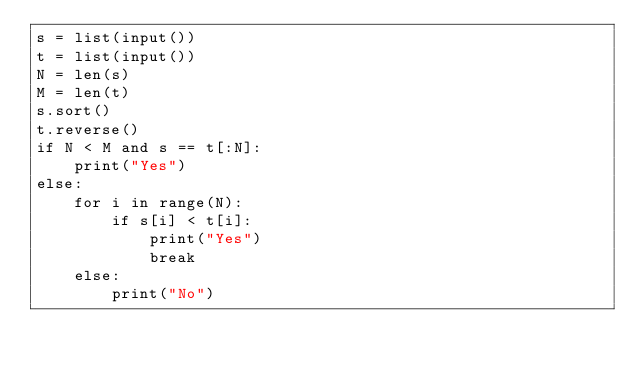<code> <loc_0><loc_0><loc_500><loc_500><_Python_>s = list(input())
t = list(input())
N = len(s)
M = len(t)
s.sort()
t.reverse()
if N < M and s == t[:N]:
    print("Yes")
else:
    for i in range(N):
        if s[i] < t[i]:
            print("Yes")
            break
    else:
        print("No")</code> 